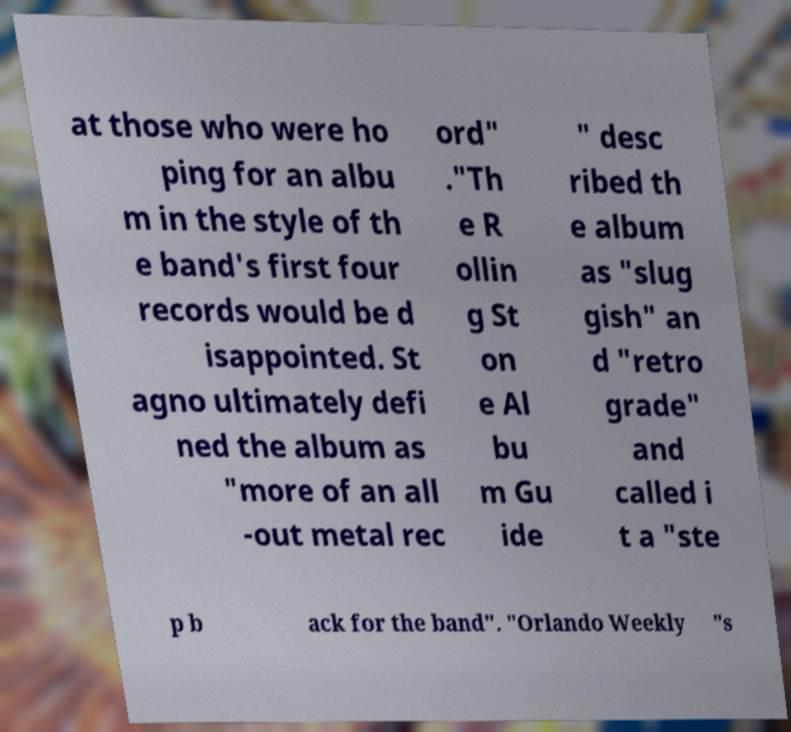I need the written content from this picture converted into text. Can you do that? at those who were ho ping for an albu m in the style of th e band's first four records would be d isappointed. St agno ultimately defi ned the album as "more of an all -out metal rec ord" ."Th e R ollin g St on e Al bu m Gu ide " desc ribed th e album as "slug gish" an d "retro grade" and called i t a "ste p b ack for the band". "Orlando Weekly "s 